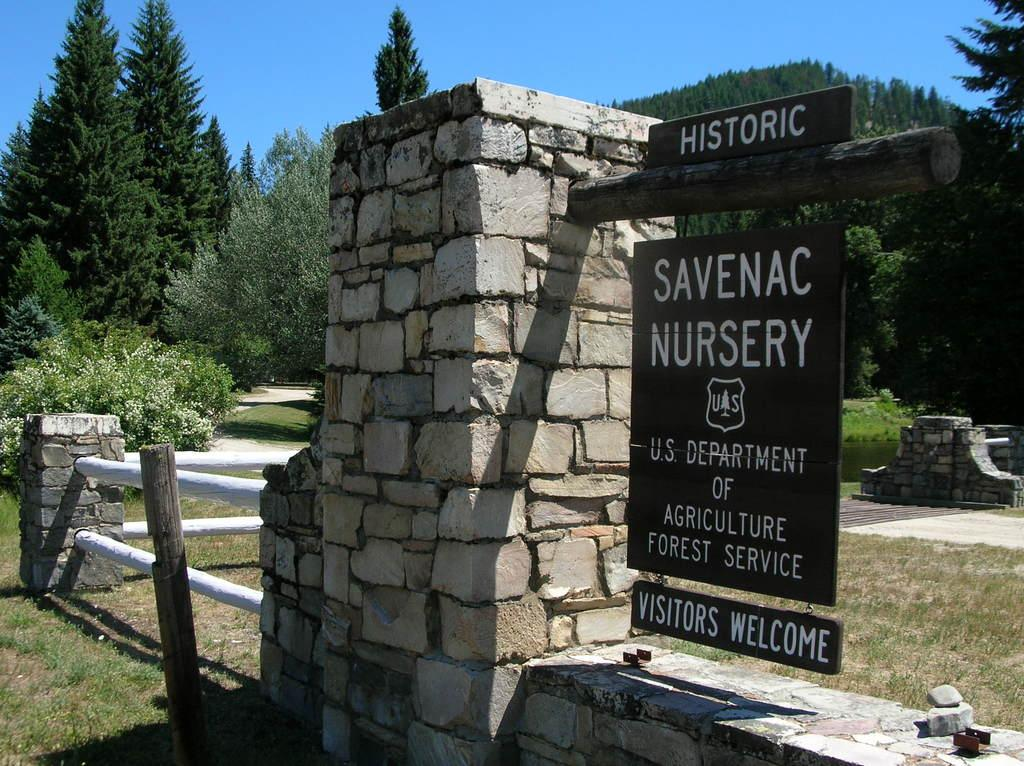What type of vegetation is present in the image? There are trees in the image. What structure can be seen in the image? There is a board in the image. What type of barrier is visible in the image? There is a fence in the image. What type of man-made structure is present in the image? There is a wall in the image. What type of ground surface is visible at the bottom of the image? There is grass at the bottom of the image. What part of the natural environment is visible in the background of the image? There is sky visible in the background of the image. Where are the kittens playing in the image? There are no kittens present in the image. What type of books can be found in the library depicted in the image? There is no library present in the image. 